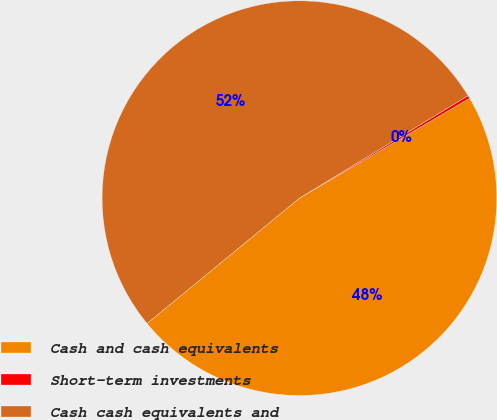Convert chart to OTSL. <chart><loc_0><loc_0><loc_500><loc_500><pie_chart><fcel>Cash and cash equivalents<fcel>Short-term investments<fcel>Cash cash equivalents and<nl><fcel>47.5%<fcel>0.24%<fcel>52.26%<nl></chart> 